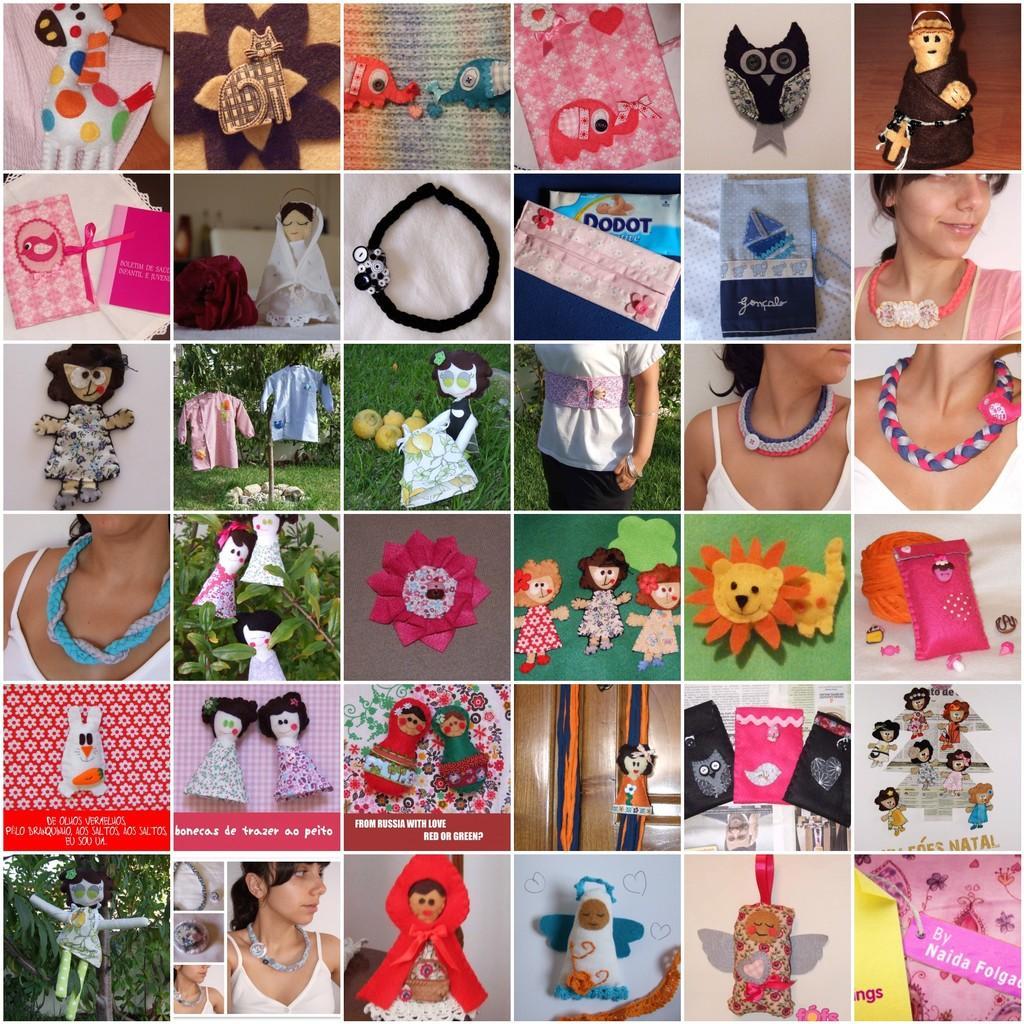Please provide a concise description of this image. In this image we can see a collage of group of pictures. In which we can see group of people, dolls, some plants and some clothes. 